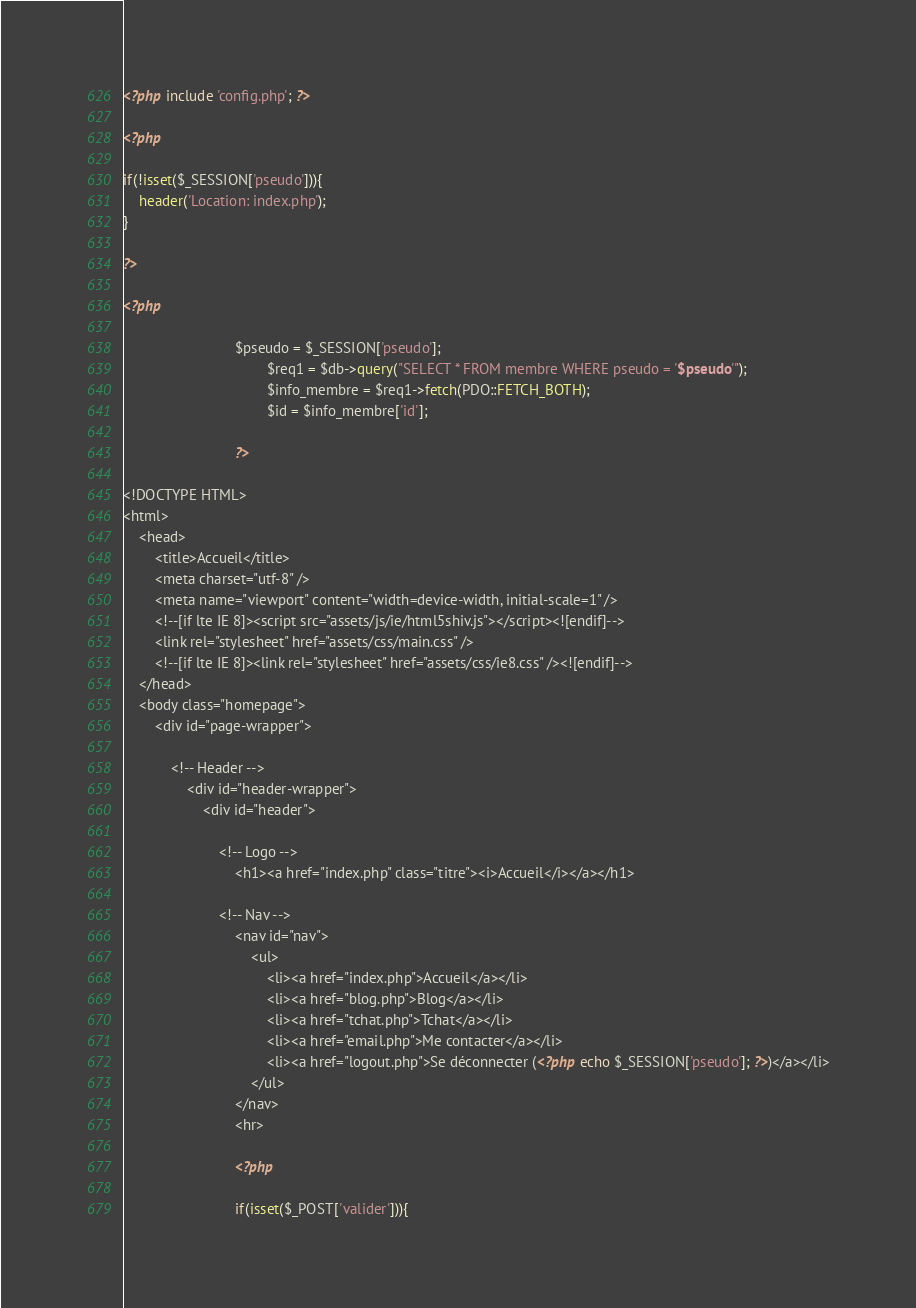<code> <loc_0><loc_0><loc_500><loc_500><_PHP_><?php include 'config.php'; ?>

<?php

if(!isset($_SESSION['pseudo'])){
	header('Location: index.php');
}

?>

<?php 

							$pseudo = $_SESSION['pseudo'];
									$req1 = $db->query("SELECT * FROM membre WHERE pseudo = '$pseudo'");
									$info_membre = $req1->fetch(PDO::FETCH_BOTH);
									$id = $info_membre['id'];

							?>

<!DOCTYPE HTML>
<html>
	<head>
		<title>Accueil</title>
		<meta charset="utf-8" />
		<meta name="viewport" content="width=device-width, initial-scale=1" />
		<!--[if lte IE 8]><script src="assets/js/ie/html5shiv.js"></script><![endif]-->
		<link rel="stylesheet" href="assets/css/main.css" />
		<!--[if lte IE 8]><link rel="stylesheet" href="assets/css/ie8.css" /><![endif]-->
	</head>
	<body class="homepage">
		<div id="page-wrapper">

			<!-- Header -->
				<div id="header-wrapper">
					<div id="header">

						<!-- Logo -->
							<h1><a href="index.php" class="titre"><i>Accueil</i></a></h1>

						<!-- Nav -->
							<nav id="nav">
								<ul>
									<li><a href="index.php">Accueil</a></li>
									<li><a href="blog.php">Blog</a></li>
									<li><a href="tchat.php">Tchat</a></li>
									<li><a href="email.php">Me contacter</a></li>
									<li><a href="logout.php">Se déconnecter (<?php echo $_SESSION['pseudo']; ?>)</a></li>
								</ul>
							</nav>
							<hr>

							<?php

							if(isset($_POST['valider'])){</code> 